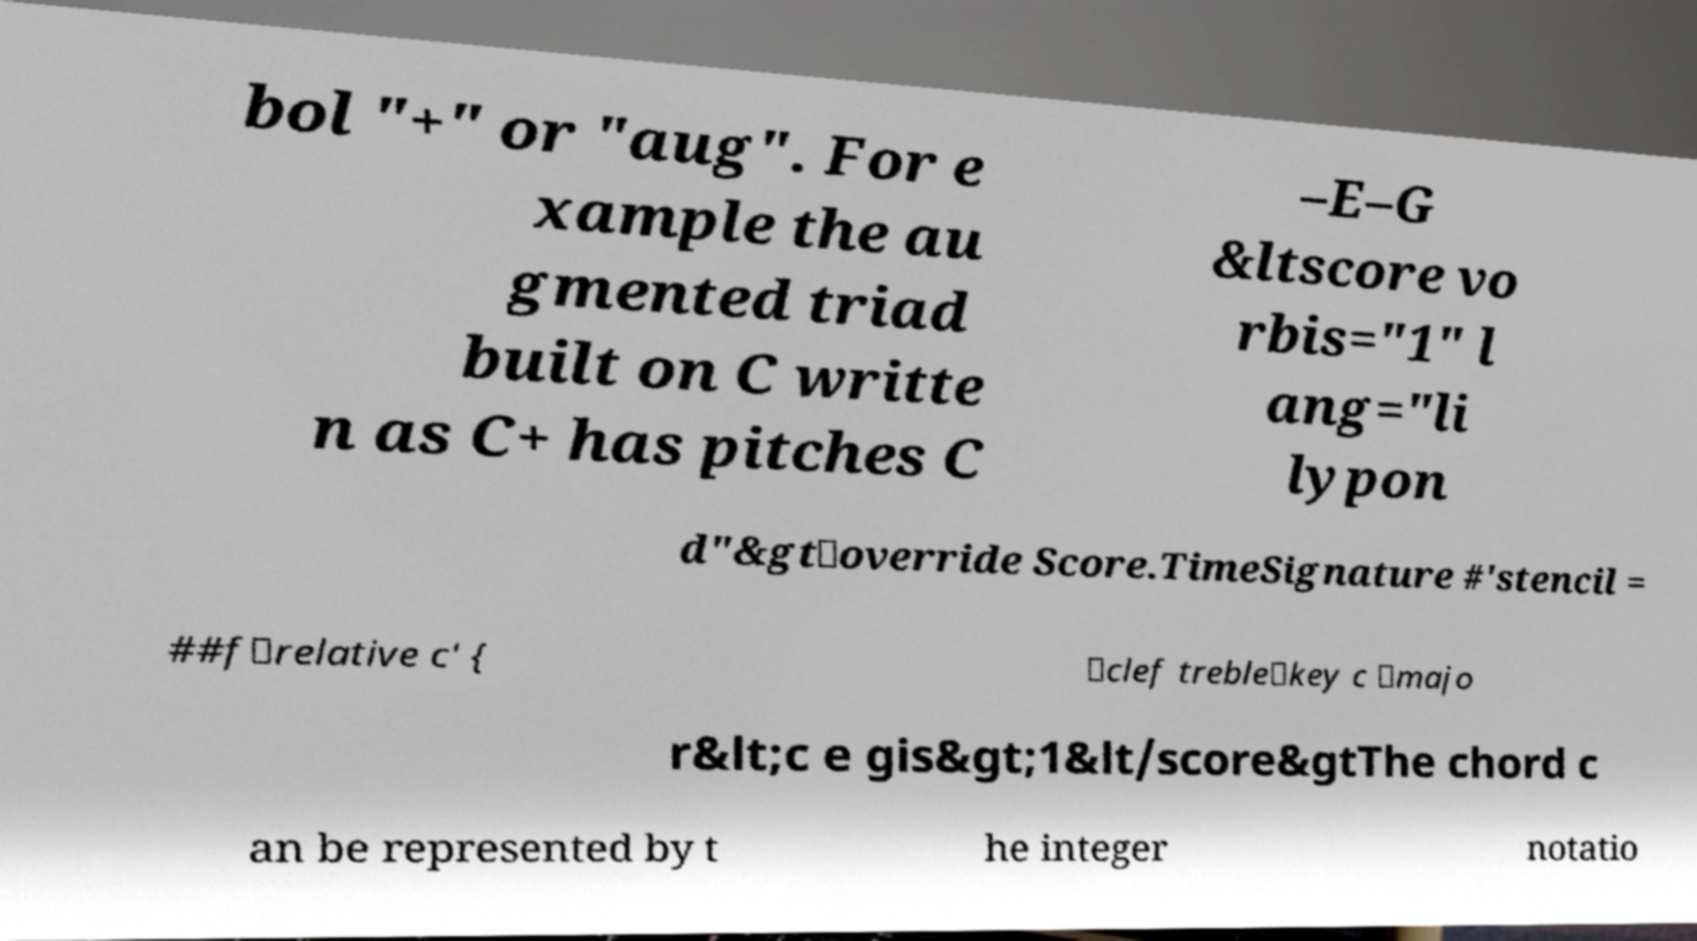For documentation purposes, I need the text within this image transcribed. Could you provide that? bol "+" or "aug". For e xample the au gmented triad built on C writte n as C+ has pitches C –E–G &ltscore vo rbis="1" l ang="li lypon d"&gt\override Score.TimeSignature #'stencil = ##f\relative c' { \clef treble\key c \majo r&lt;c e gis&gt;1&lt/score&gtThe chord c an be represented by t he integer notatio 